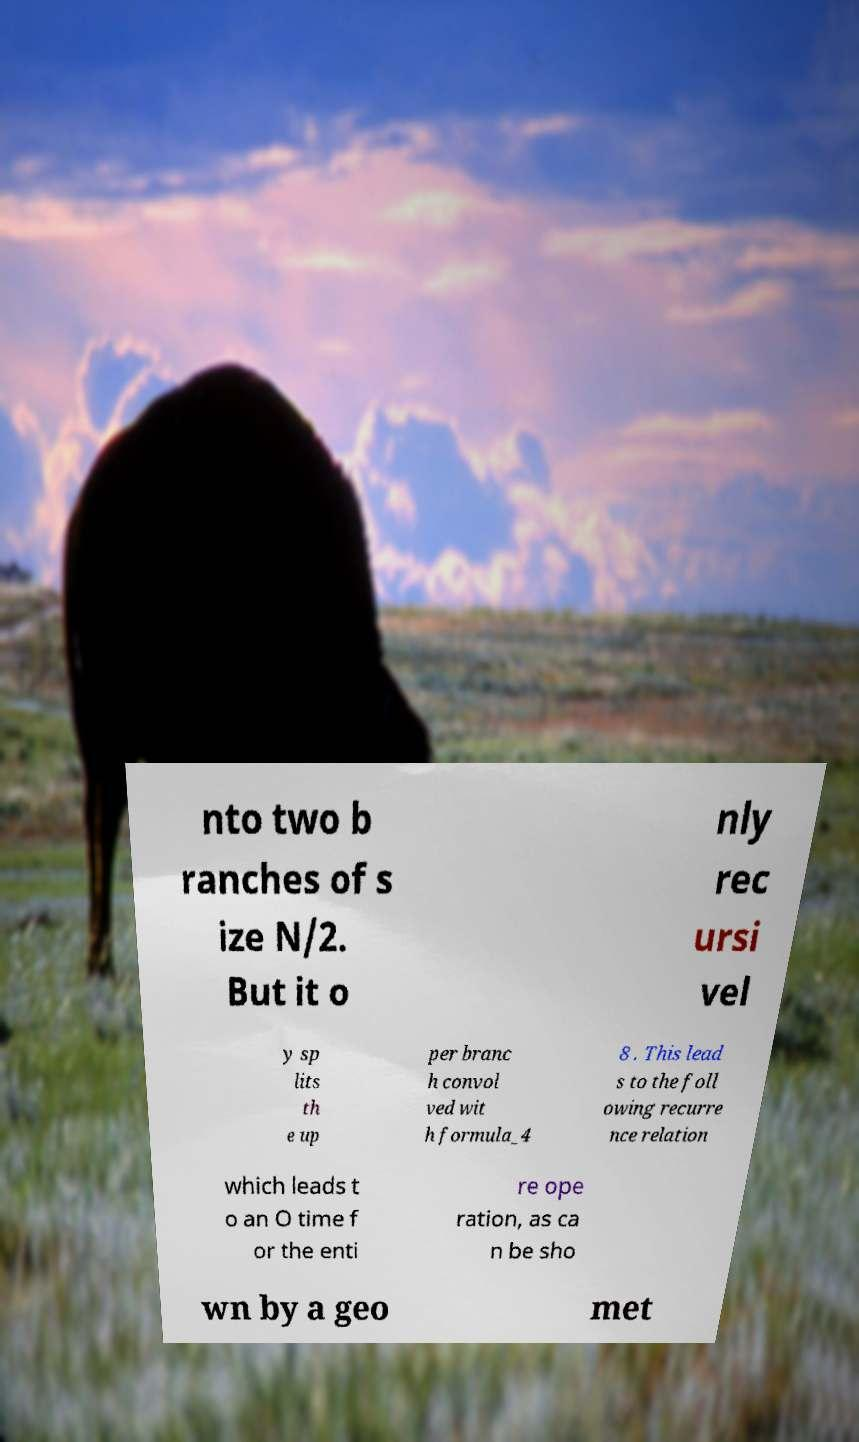Can you read and provide the text displayed in the image?This photo seems to have some interesting text. Can you extract and type it out for me? nto two b ranches of s ize N/2. But it o nly rec ursi vel y sp lits th e up per branc h convol ved wit h formula_4 8 . This lead s to the foll owing recurre nce relation which leads t o an O time f or the enti re ope ration, as ca n be sho wn by a geo met 